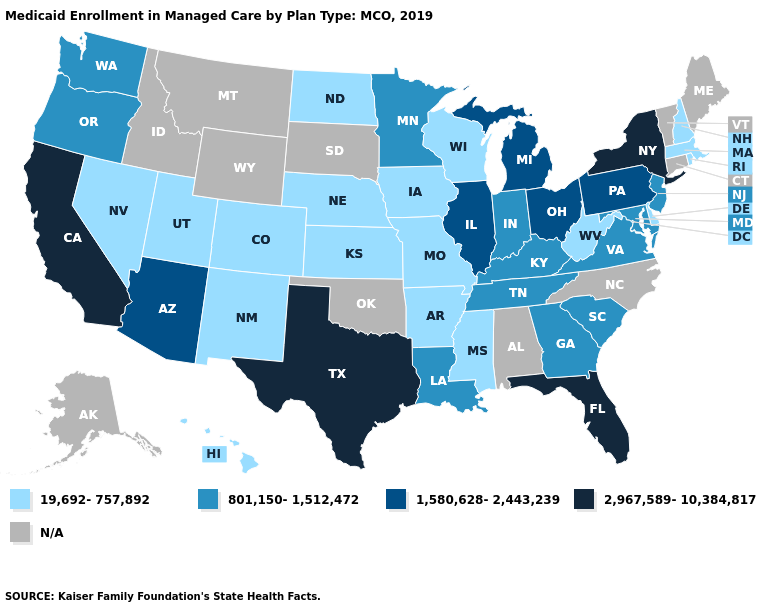Which states have the lowest value in the MidWest?
Short answer required. Iowa, Kansas, Missouri, Nebraska, North Dakota, Wisconsin. Which states have the lowest value in the USA?
Give a very brief answer. Arkansas, Colorado, Delaware, Hawaii, Iowa, Kansas, Massachusetts, Mississippi, Missouri, Nebraska, Nevada, New Hampshire, New Mexico, North Dakota, Rhode Island, Utah, West Virginia, Wisconsin. Which states have the highest value in the USA?
Short answer required. California, Florida, New York, Texas. Among the states that border Missouri , does Iowa have the highest value?
Concise answer only. No. Name the states that have a value in the range N/A?
Give a very brief answer. Alabama, Alaska, Connecticut, Idaho, Maine, Montana, North Carolina, Oklahoma, South Dakota, Vermont, Wyoming. Does the first symbol in the legend represent the smallest category?
Give a very brief answer. Yes. Does New York have the highest value in the Northeast?
Keep it brief. Yes. Does the map have missing data?
Give a very brief answer. Yes. Which states have the lowest value in the MidWest?
Be succinct. Iowa, Kansas, Missouri, Nebraska, North Dakota, Wisconsin. How many symbols are there in the legend?
Write a very short answer. 5. What is the highest value in the Northeast ?
Quick response, please. 2,967,589-10,384,817. Name the states that have a value in the range 19,692-757,892?
Write a very short answer. Arkansas, Colorado, Delaware, Hawaii, Iowa, Kansas, Massachusetts, Mississippi, Missouri, Nebraska, Nevada, New Hampshire, New Mexico, North Dakota, Rhode Island, Utah, West Virginia, Wisconsin. Name the states that have a value in the range 2,967,589-10,384,817?
Be succinct. California, Florida, New York, Texas. Name the states that have a value in the range 1,580,628-2,443,239?
Concise answer only. Arizona, Illinois, Michigan, Ohio, Pennsylvania. Name the states that have a value in the range 19,692-757,892?
Short answer required. Arkansas, Colorado, Delaware, Hawaii, Iowa, Kansas, Massachusetts, Mississippi, Missouri, Nebraska, Nevada, New Hampshire, New Mexico, North Dakota, Rhode Island, Utah, West Virginia, Wisconsin. 